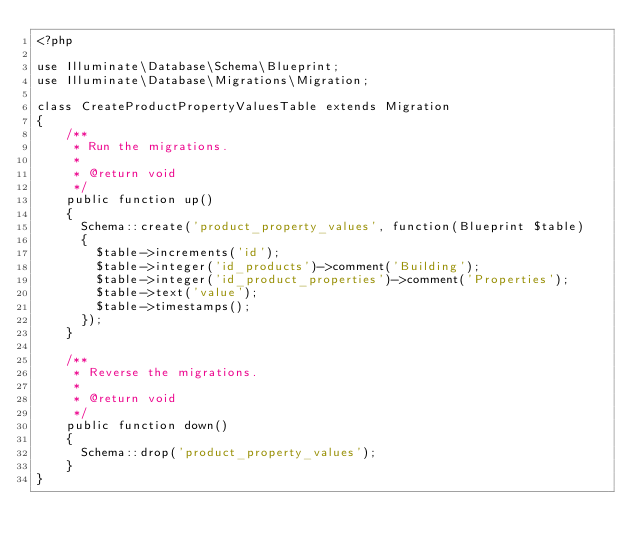Convert code to text. <code><loc_0><loc_0><loc_500><loc_500><_PHP_><?php

use Illuminate\Database\Schema\Blueprint;
use Illuminate\Database\Migrations\Migration;

class CreateProductPropertyValuesTable extends Migration
{
    /**
     * Run the migrations.
     *
     * @return void
     */
    public function up()
    {
      Schema::create('product_property_values', function(Blueprint $table)
      {
        $table->increments('id');
        $table->integer('id_products')->comment('Building');
        $table->integer('id_product_properties')->comment('Properties');
        $table->text('value');
        $table->timestamps();
      });
    }

    /**
     * Reverse the migrations.
     *
     * @return void
     */
    public function down()
    {
      Schema::drop('product_property_values');
    }
}
</code> 